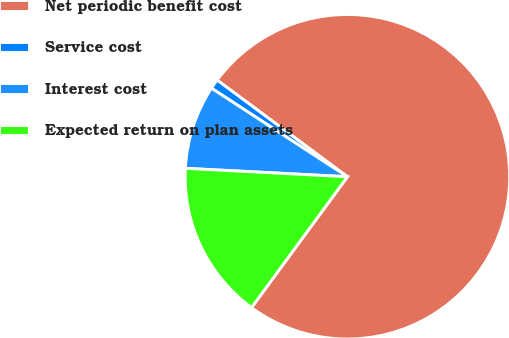<chart> <loc_0><loc_0><loc_500><loc_500><pie_chart><fcel>Net periodic benefit cost<fcel>Service cost<fcel>Interest cost<fcel>Expected return on plan assets<nl><fcel>74.91%<fcel>0.97%<fcel>8.36%<fcel>15.76%<nl></chart> 